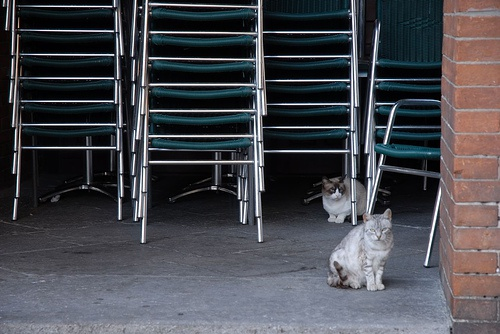Describe the objects in this image and their specific colors. I can see chair in black, gray, darkgray, and white tones, chair in black, gray, darkgray, and white tones, chair in black, gray, blue, and darkblue tones, chair in black, gray, darkblue, and white tones, and cat in black, darkgray, lightgray, and gray tones in this image. 